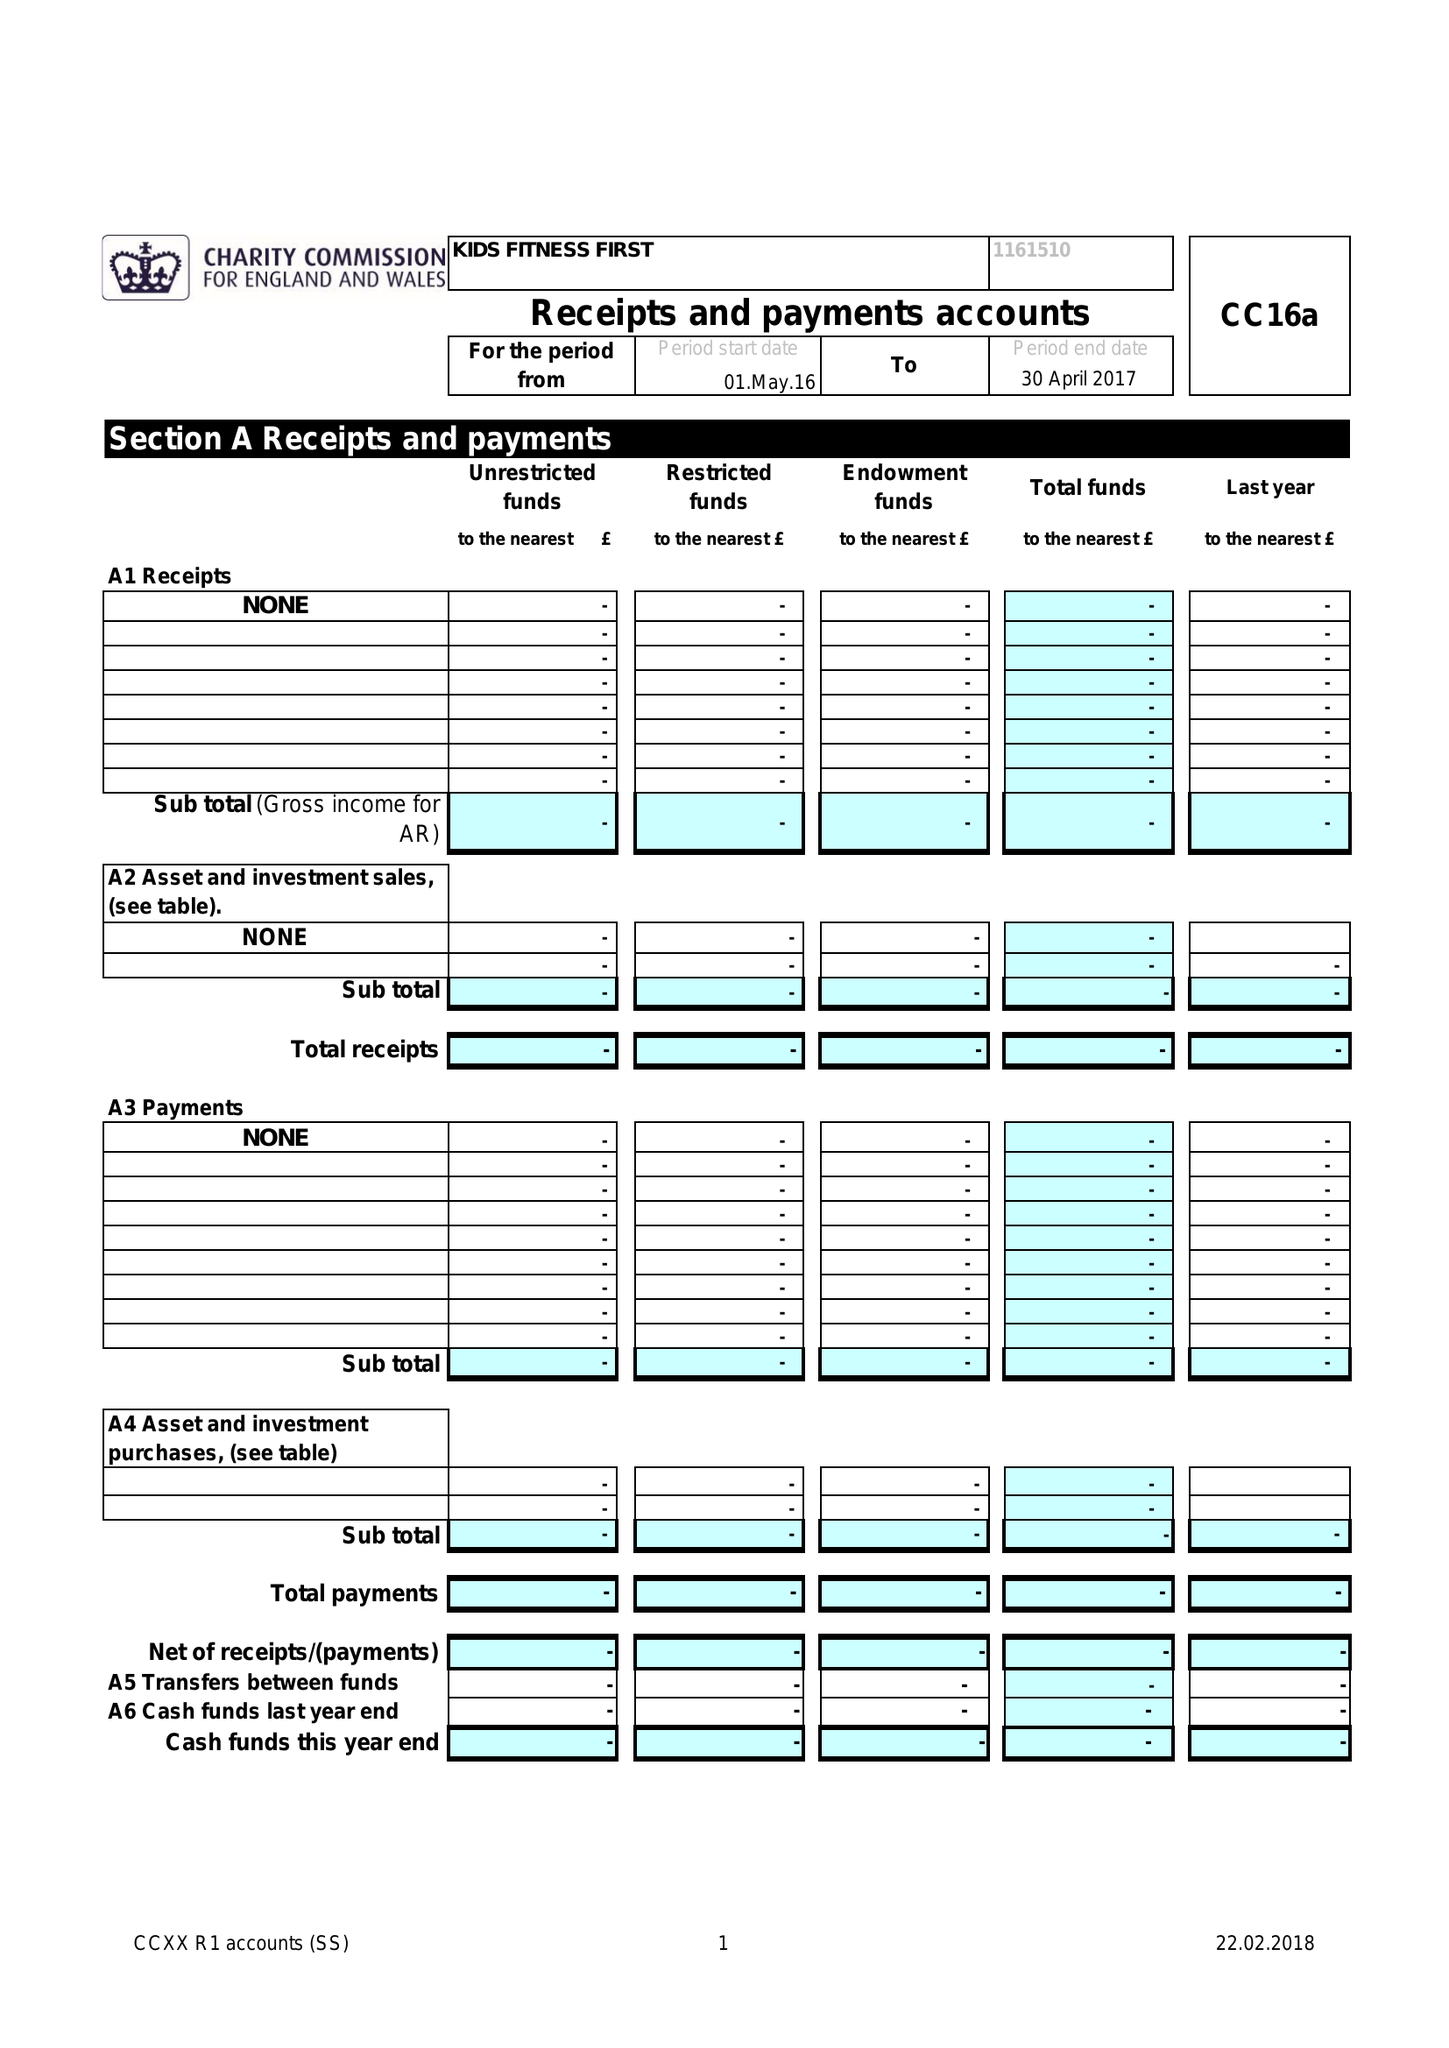What is the value for the address__street_line?
Answer the question using a single word or phrase. 132-134 GREAT ANCOATS STREET 